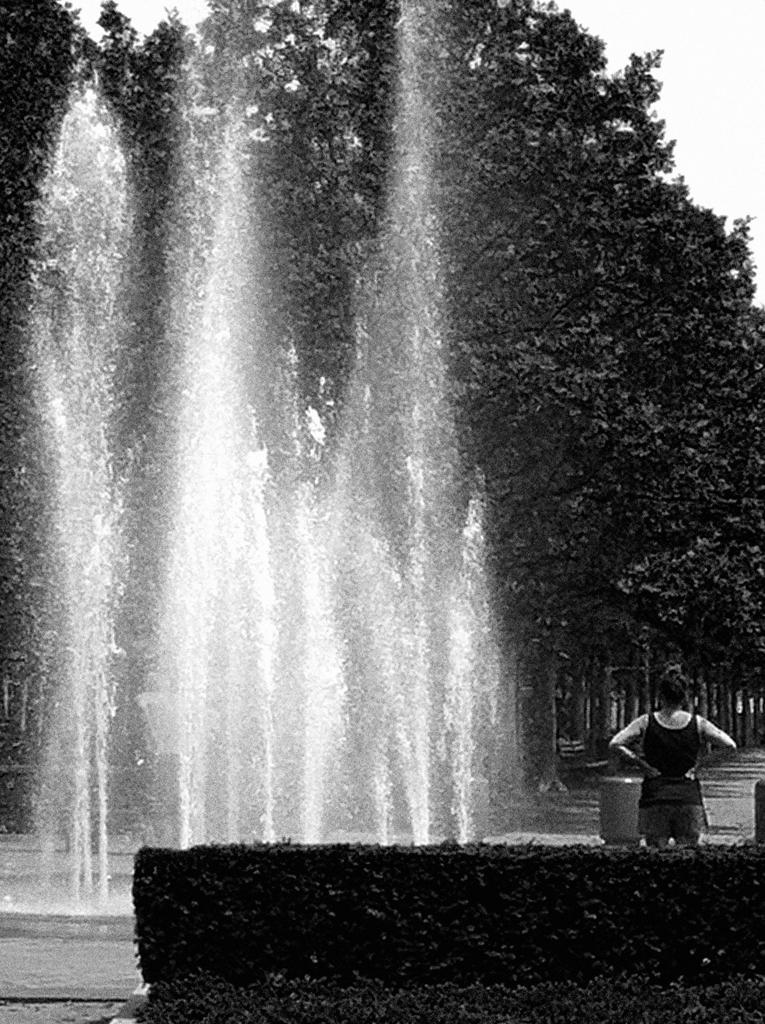What type of living organisms can be seen in the image? Plants can be seen in the image. What is the person standing near in the image? The person is standing near a water fountain. What can be seen in the background of the image? There are trees and the sky visible in the background of the image. What is the person's tongue doing in the image? There is no indication of the person's tongue in the image. What is the person's desire in the image? There is no information about the person's desires in the image. Can you see a basketball in the image? There is no basketball present in the image. 